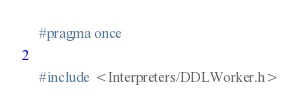Convert code to text. <code><loc_0><loc_0><loc_500><loc_500><_C_>#pragma once

#include <Interpreters/DDLWorker.h></code> 